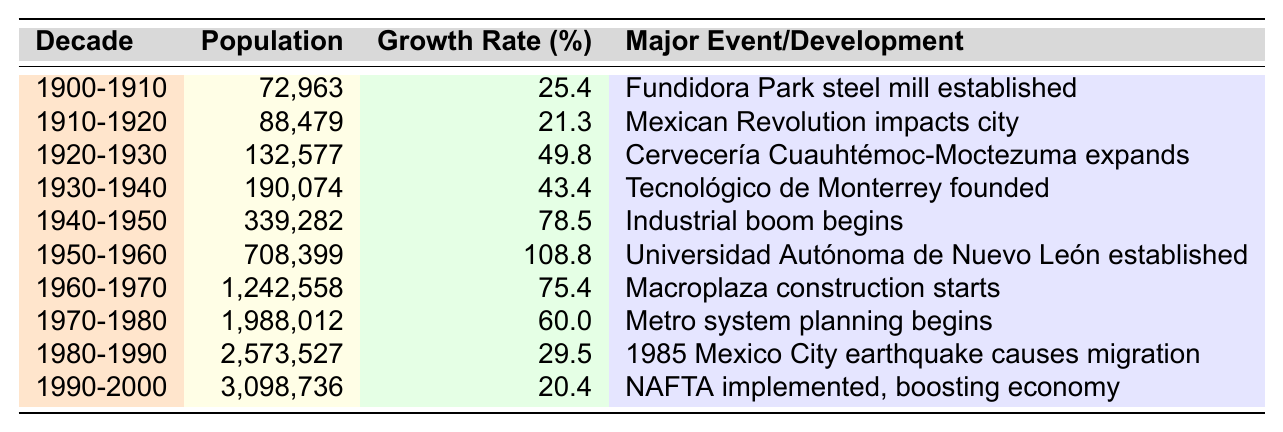What was the population of Monterrey in 1950-1960? The table indicates the population for the decade 1950-1960 is 708,399.
Answer: 708,399 Which decade had the highest growth rate? The highest growth rate can be found by comparing the "Growth Rate (%)" values. The decade 1950-1960 has a growth rate of 108.8%, which is the highest among all decades.
Answer: 1950-1960 What was the major event in Monterrey during the decade of 1940-1950? Referring to the table, during the decade 1940-1950, the major event listed is the "Industrial boom begins."
Answer: Industrial boom begins How much did the population grow from 1920-1930 to 1930-1940? The population in 1920-1930 was 132,577 and in 1930-1940 it was 190,074. The growth is calculated as 190,074 - 132,577 = 57,497.
Answer: 57,497 What was the average growth rate from 1900 to 2000? First, we sum the growth rates: (25.4 + 21.3 + 49.8 + 43.4 + 78.5 + 108.8 + 75.4 + 60.0 + 29.5 + 20.4) = 512.1. Then, we divide by the number of decades (10): 512.1 / 10 = 51.21.
Answer: 51.21 Did the population of Monterrey ever decrease in any decade between 1900 and 2000? Referring to the population values across the decades, there are no indications of a decreasing population; thus, the answer is no.
Answer: No Which decade experienced a significant impact due to the Mexican Revolution? The table states that during the decade 1910-1920, the impact of the Mexican Revolution affected the city, which is indicated under the "Major Event/Development" column.
Answer: 1910-1920 By how much did the population increase from 1980-1990? The population for 1980-1990 is 2,573,527 and for the previous decade (1970-1980) is 1,988,012. The increase is calculated as 2,573,527 - 1,988,012 = 585,515.
Answer: 585,515 What population milestone did Monterrey cross in the decade of 1990-2000? According to the table, Monterrey's population surpassed 3 million during the decade of 1990-2000, reaching 3,098,736.
Answer: 3 million Which event was related to the economic boost in Monterrey during the decade of 1990-2000? The implementation of NAFTA is noted in the table as the significant event that boosted the economy during the 1990-2000 decade.
Answer: NAFTA implemented What was the percentage growth from the decade of 1940-1950 to 1950-1960? For 1940-1950, the growth rate was 78.5%, and for 1950-1960, it was 108.8%. The difference is calculated as 108.8 - 78.5 = 30.3%.
Answer: 30.3% 